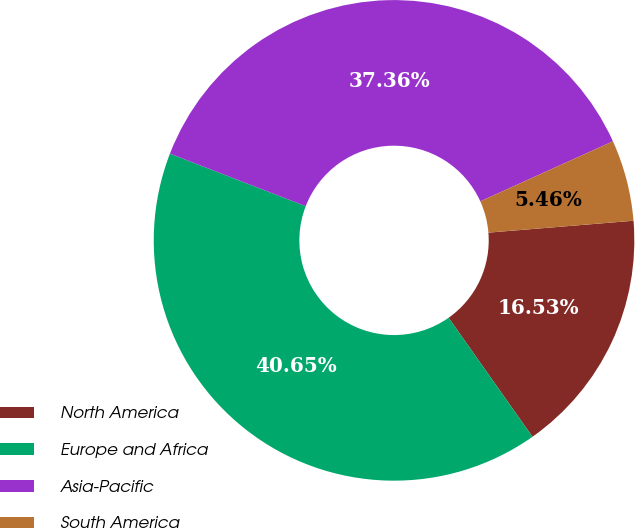Convert chart. <chart><loc_0><loc_0><loc_500><loc_500><pie_chart><fcel>North America<fcel>Europe and Africa<fcel>Asia-Pacific<fcel>South America<nl><fcel>16.53%<fcel>40.65%<fcel>37.36%<fcel>5.46%<nl></chart> 